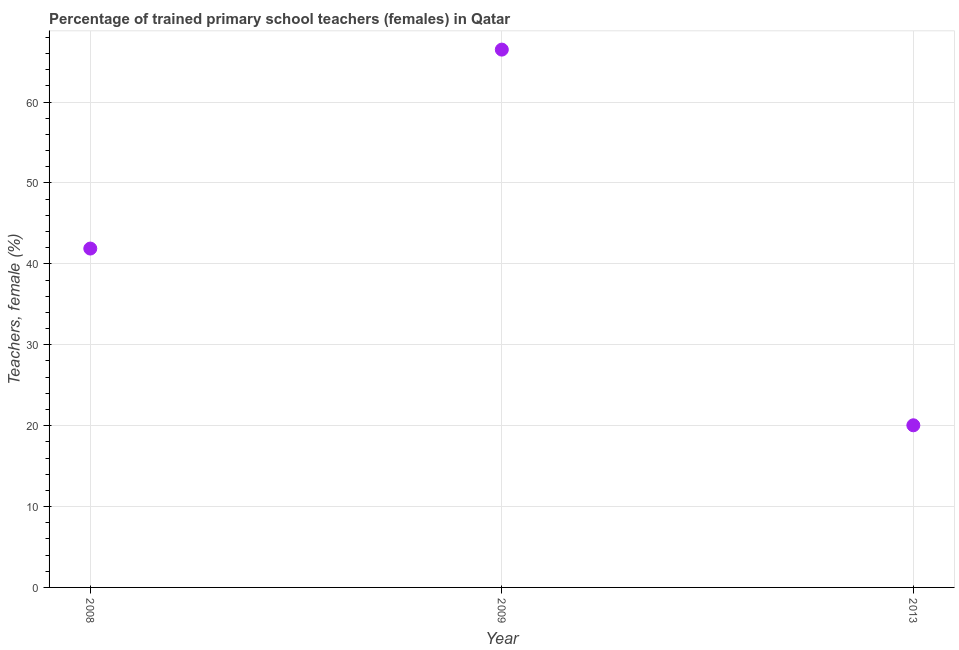What is the percentage of trained female teachers in 2008?
Offer a terse response. 41.89. Across all years, what is the maximum percentage of trained female teachers?
Keep it short and to the point. 66.49. Across all years, what is the minimum percentage of trained female teachers?
Your response must be concise. 20.04. In which year was the percentage of trained female teachers maximum?
Provide a short and direct response. 2009. What is the sum of the percentage of trained female teachers?
Give a very brief answer. 128.43. What is the difference between the percentage of trained female teachers in 2008 and 2009?
Your answer should be compact. -24.59. What is the average percentage of trained female teachers per year?
Give a very brief answer. 42.81. What is the median percentage of trained female teachers?
Ensure brevity in your answer.  41.89. What is the ratio of the percentage of trained female teachers in 2008 to that in 2009?
Provide a short and direct response. 0.63. Is the percentage of trained female teachers in 2009 less than that in 2013?
Provide a short and direct response. No. What is the difference between the highest and the second highest percentage of trained female teachers?
Your answer should be very brief. 24.59. What is the difference between the highest and the lowest percentage of trained female teachers?
Ensure brevity in your answer.  46.44. How many dotlines are there?
Your answer should be compact. 1. How many years are there in the graph?
Your answer should be compact. 3. Does the graph contain grids?
Your answer should be very brief. Yes. What is the title of the graph?
Make the answer very short. Percentage of trained primary school teachers (females) in Qatar. What is the label or title of the Y-axis?
Give a very brief answer. Teachers, female (%). What is the Teachers, female (%) in 2008?
Your answer should be compact. 41.89. What is the Teachers, female (%) in 2009?
Your answer should be very brief. 66.49. What is the Teachers, female (%) in 2013?
Make the answer very short. 20.04. What is the difference between the Teachers, female (%) in 2008 and 2009?
Ensure brevity in your answer.  -24.59. What is the difference between the Teachers, female (%) in 2008 and 2013?
Ensure brevity in your answer.  21.85. What is the difference between the Teachers, female (%) in 2009 and 2013?
Your answer should be compact. 46.44. What is the ratio of the Teachers, female (%) in 2008 to that in 2009?
Give a very brief answer. 0.63. What is the ratio of the Teachers, female (%) in 2008 to that in 2013?
Ensure brevity in your answer.  2.09. What is the ratio of the Teachers, female (%) in 2009 to that in 2013?
Provide a short and direct response. 3.32. 